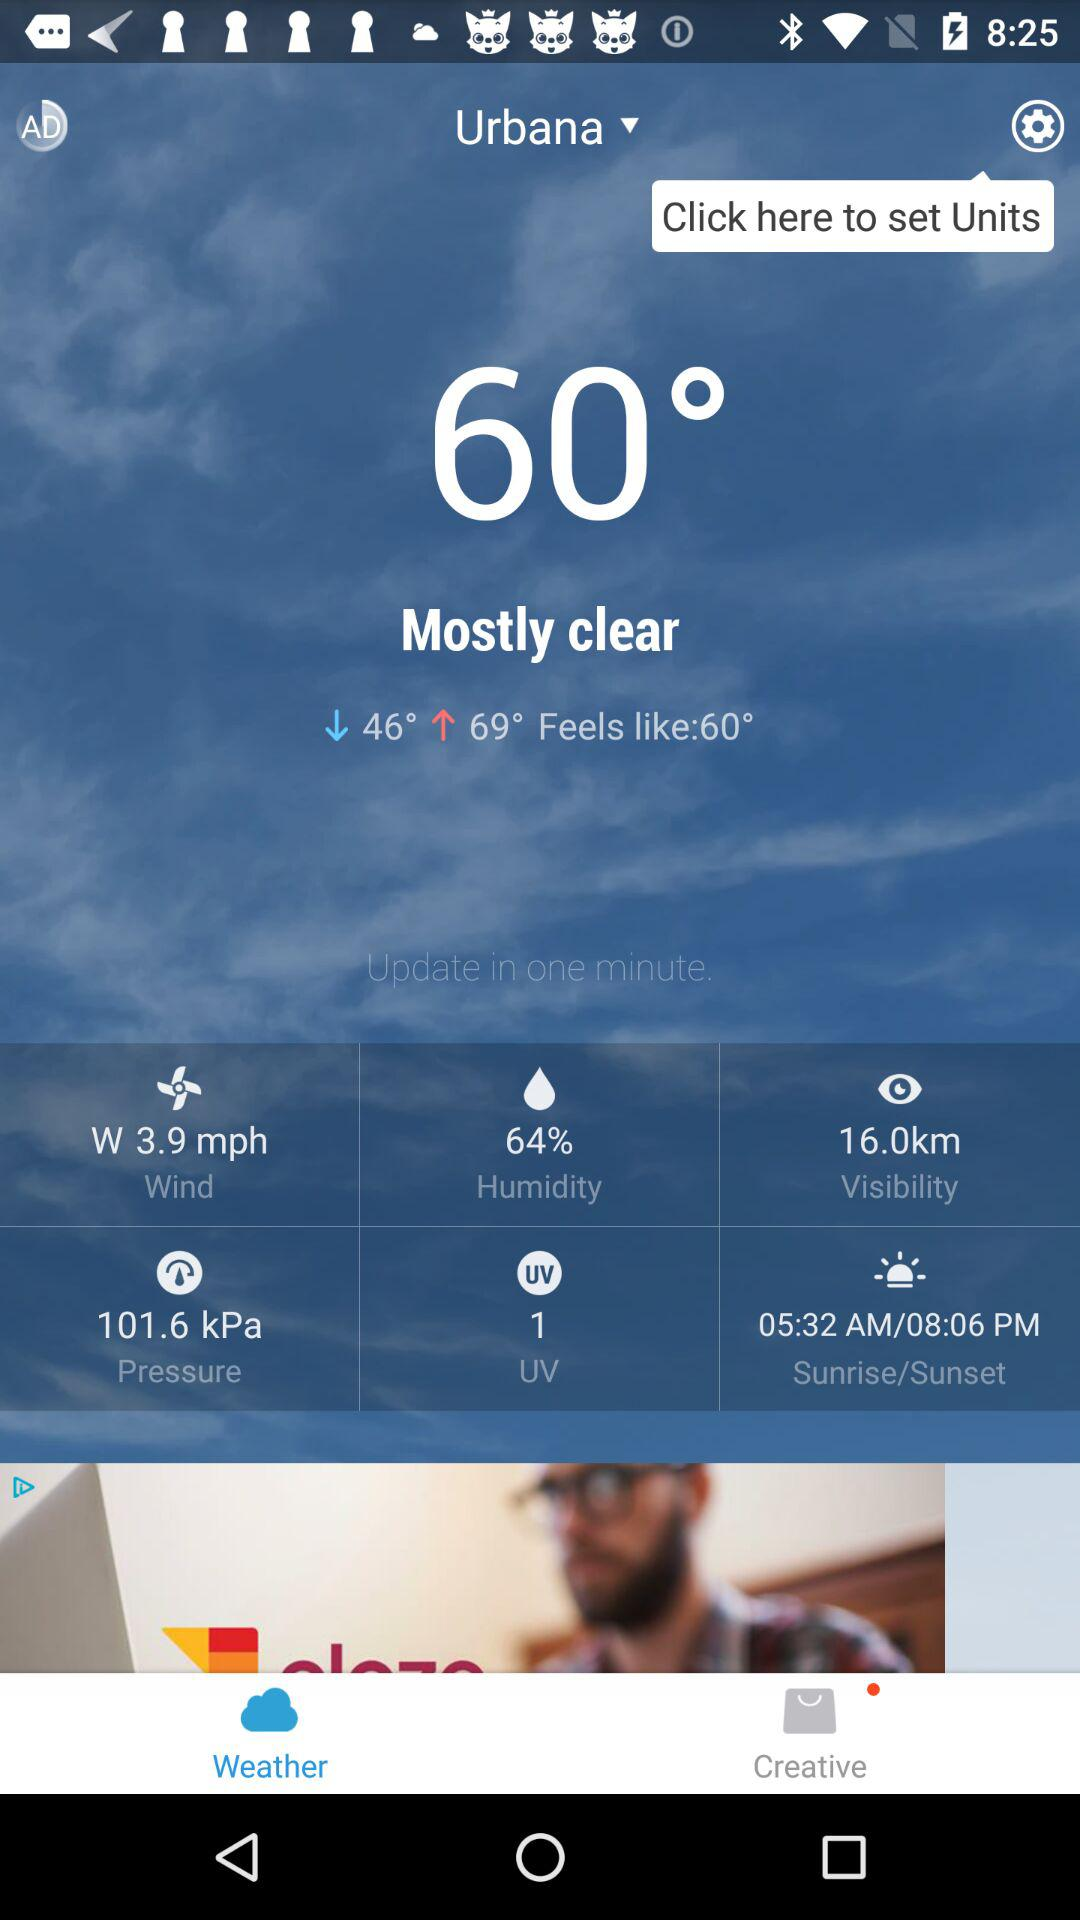What is the humidity of the current weather?
Answer the question using a single word or phrase. 64% 